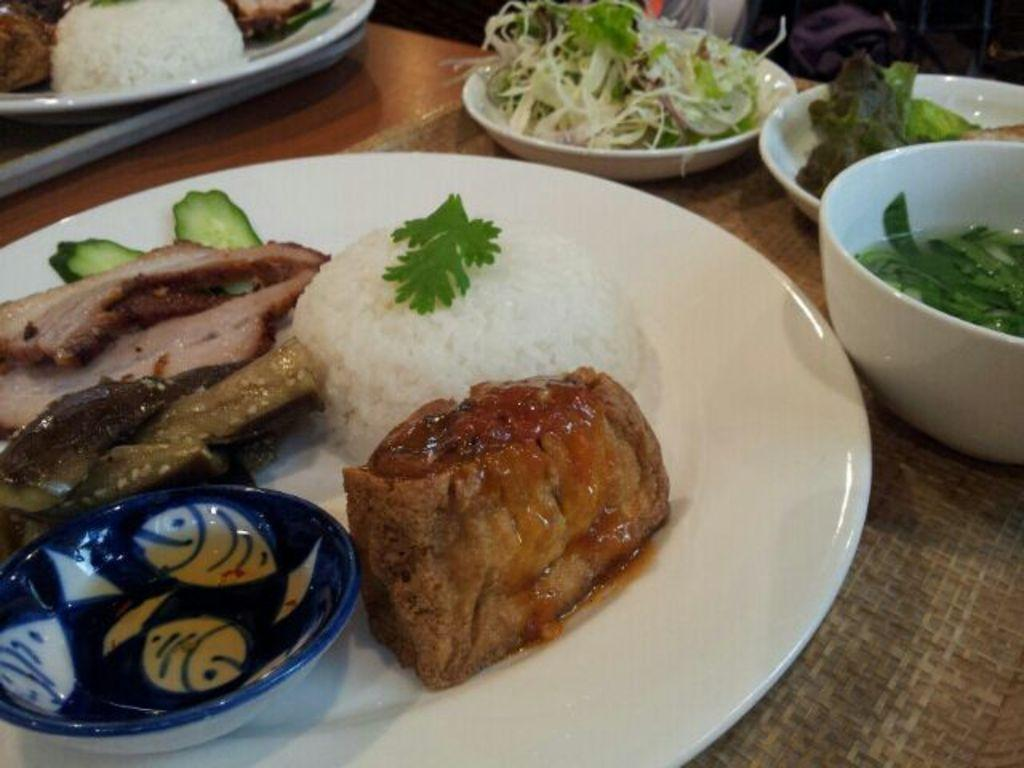What types of food items can be seen in the image? The food items in the image have brown, white, and green colors. How are the food items arranged in the image? The food items are in plates. What color are the plates that hold the food items? The plates are white in color. What type of coil is present in the image? There is no coil present in the image; it features food items in plates. What company is responsible for the food items in the image? There is no information about a company in the image; it only shows food items in plates. 